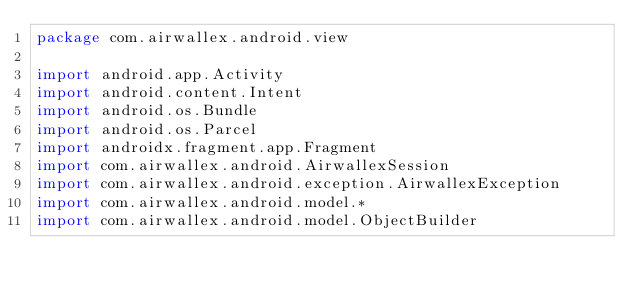Convert code to text. <code><loc_0><loc_0><loc_500><loc_500><_Kotlin_>package com.airwallex.android.view

import android.app.Activity
import android.content.Intent
import android.os.Bundle
import android.os.Parcel
import androidx.fragment.app.Fragment
import com.airwallex.android.AirwallexSession
import com.airwallex.android.exception.AirwallexException
import com.airwallex.android.model.*
import com.airwallex.android.model.ObjectBuilder</code> 